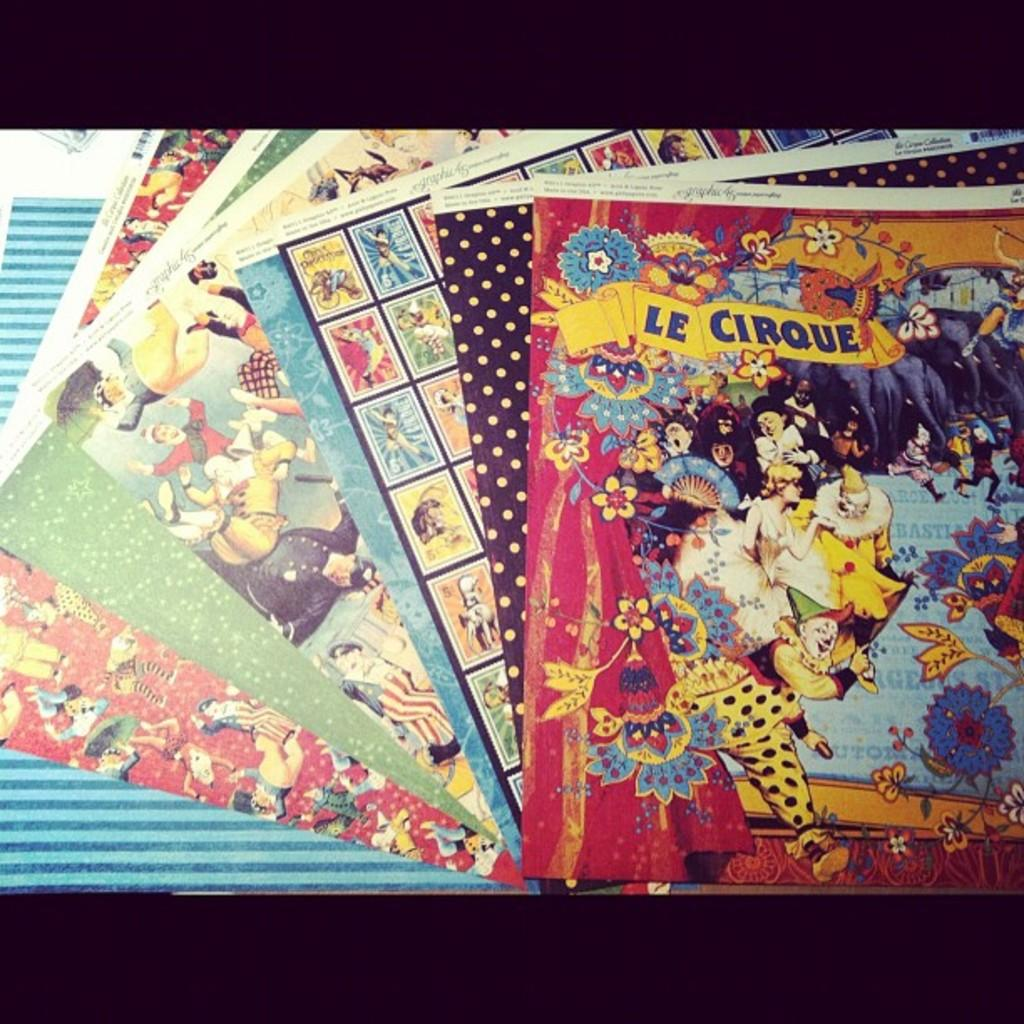<image>
Render a clear and concise summary of the photo. Le Cirque is among several other colorful books. 